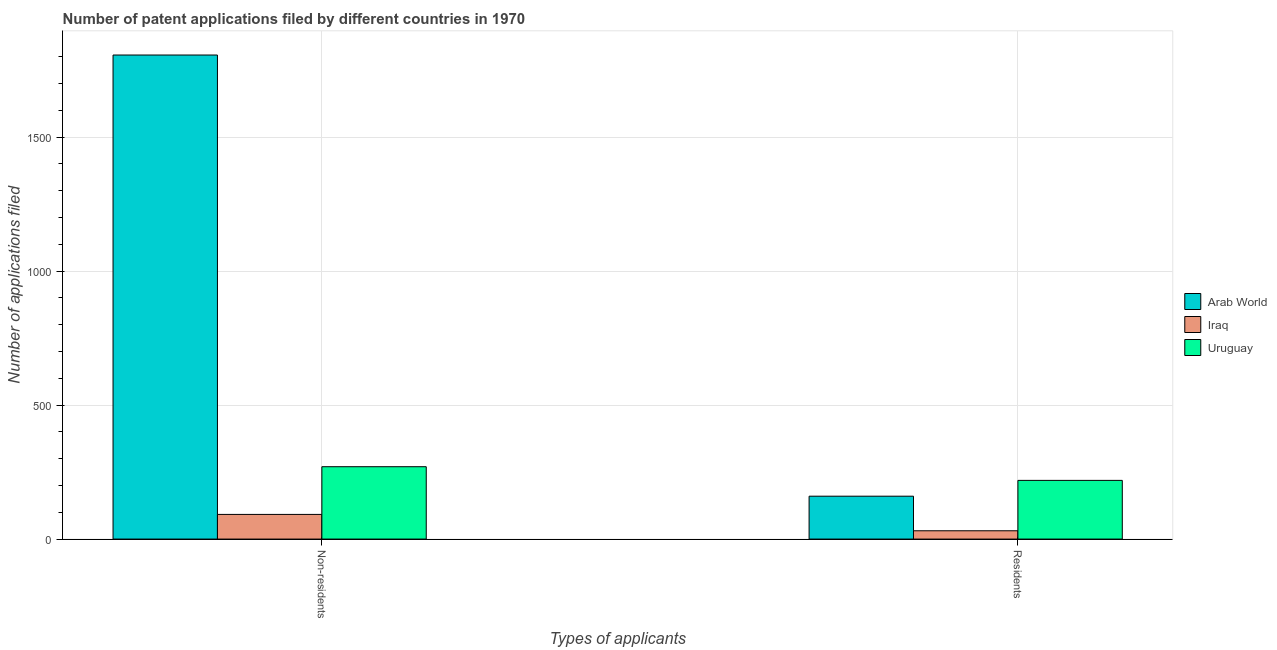How many groups of bars are there?
Your answer should be compact. 2. Are the number of bars per tick equal to the number of legend labels?
Provide a short and direct response. Yes. How many bars are there on the 2nd tick from the left?
Provide a succinct answer. 3. How many bars are there on the 2nd tick from the right?
Your answer should be very brief. 3. What is the label of the 2nd group of bars from the left?
Make the answer very short. Residents. What is the number of patent applications by non residents in Arab World?
Give a very brief answer. 1806. Across all countries, what is the maximum number of patent applications by residents?
Provide a succinct answer. 219. Across all countries, what is the minimum number of patent applications by non residents?
Provide a succinct answer. 92. In which country was the number of patent applications by residents maximum?
Offer a terse response. Uruguay. In which country was the number of patent applications by residents minimum?
Your answer should be very brief. Iraq. What is the total number of patent applications by residents in the graph?
Keep it short and to the point. 410. What is the difference between the number of patent applications by residents in Arab World and that in Iraq?
Your answer should be very brief. 129. What is the difference between the number of patent applications by non residents in Iraq and the number of patent applications by residents in Uruguay?
Your answer should be very brief. -127. What is the average number of patent applications by residents per country?
Provide a succinct answer. 136.67. What is the difference between the number of patent applications by non residents and number of patent applications by residents in Iraq?
Offer a terse response. 61. What is the ratio of the number of patent applications by non residents in Iraq to that in Arab World?
Give a very brief answer. 0.05. In how many countries, is the number of patent applications by non residents greater than the average number of patent applications by non residents taken over all countries?
Give a very brief answer. 1. What does the 1st bar from the left in Non-residents represents?
Offer a very short reply. Arab World. What does the 3rd bar from the right in Residents represents?
Provide a succinct answer. Arab World. How many bars are there?
Provide a succinct answer. 6. Are all the bars in the graph horizontal?
Your answer should be very brief. No. Does the graph contain any zero values?
Make the answer very short. No. How are the legend labels stacked?
Offer a very short reply. Vertical. What is the title of the graph?
Provide a short and direct response. Number of patent applications filed by different countries in 1970. Does "Colombia" appear as one of the legend labels in the graph?
Offer a terse response. No. What is the label or title of the X-axis?
Provide a short and direct response. Types of applicants. What is the label or title of the Y-axis?
Ensure brevity in your answer.  Number of applications filed. What is the Number of applications filed of Arab World in Non-residents?
Give a very brief answer. 1806. What is the Number of applications filed of Iraq in Non-residents?
Your answer should be compact. 92. What is the Number of applications filed of Uruguay in Non-residents?
Provide a short and direct response. 270. What is the Number of applications filed in Arab World in Residents?
Your response must be concise. 160. What is the Number of applications filed of Uruguay in Residents?
Ensure brevity in your answer.  219. Across all Types of applicants, what is the maximum Number of applications filed of Arab World?
Offer a very short reply. 1806. Across all Types of applicants, what is the maximum Number of applications filed of Iraq?
Offer a very short reply. 92. Across all Types of applicants, what is the maximum Number of applications filed in Uruguay?
Your response must be concise. 270. Across all Types of applicants, what is the minimum Number of applications filed in Arab World?
Provide a short and direct response. 160. Across all Types of applicants, what is the minimum Number of applications filed in Uruguay?
Offer a terse response. 219. What is the total Number of applications filed of Arab World in the graph?
Ensure brevity in your answer.  1966. What is the total Number of applications filed of Iraq in the graph?
Your answer should be very brief. 123. What is the total Number of applications filed of Uruguay in the graph?
Ensure brevity in your answer.  489. What is the difference between the Number of applications filed in Arab World in Non-residents and that in Residents?
Give a very brief answer. 1646. What is the difference between the Number of applications filed in Uruguay in Non-residents and that in Residents?
Offer a very short reply. 51. What is the difference between the Number of applications filed of Arab World in Non-residents and the Number of applications filed of Iraq in Residents?
Provide a succinct answer. 1775. What is the difference between the Number of applications filed in Arab World in Non-residents and the Number of applications filed in Uruguay in Residents?
Offer a very short reply. 1587. What is the difference between the Number of applications filed of Iraq in Non-residents and the Number of applications filed of Uruguay in Residents?
Offer a terse response. -127. What is the average Number of applications filed of Arab World per Types of applicants?
Offer a terse response. 983. What is the average Number of applications filed in Iraq per Types of applicants?
Keep it short and to the point. 61.5. What is the average Number of applications filed of Uruguay per Types of applicants?
Offer a very short reply. 244.5. What is the difference between the Number of applications filed in Arab World and Number of applications filed in Iraq in Non-residents?
Keep it short and to the point. 1714. What is the difference between the Number of applications filed of Arab World and Number of applications filed of Uruguay in Non-residents?
Your response must be concise. 1536. What is the difference between the Number of applications filed in Iraq and Number of applications filed in Uruguay in Non-residents?
Keep it short and to the point. -178. What is the difference between the Number of applications filed in Arab World and Number of applications filed in Iraq in Residents?
Your response must be concise. 129. What is the difference between the Number of applications filed of Arab World and Number of applications filed of Uruguay in Residents?
Give a very brief answer. -59. What is the difference between the Number of applications filed of Iraq and Number of applications filed of Uruguay in Residents?
Give a very brief answer. -188. What is the ratio of the Number of applications filed in Arab World in Non-residents to that in Residents?
Offer a terse response. 11.29. What is the ratio of the Number of applications filed of Iraq in Non-residents to that in Residents?
Provide a succinct answer. 2.97. What is the ratio of the Number of applications filed in Uruguay in Non-residents to that in Residents?
Provide a short and direct response. 1.23. What is the difference between the highest and the second highest Number of applications filed of Arab World?
Your response must be concise. 1646. What is the difference between the highest and the lowest Number of applications filed of Arab World?
Keep it short and to the point. 1646. What is the difference between the highest and the lowest Number of applications filed in Iraq?
Offer a very short reply. 61. 